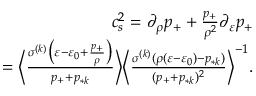<formula> <loc_0><loc_0><loc_500><loc_500>\begin{array} { r } { c _ { s } ^ { 2 } = \partial _ { \rho } p _ { + } + \frac { p _ { + } } { \rho ^ { 2 } } \partial _ { \varepsilon } p _ { + } } \\ { = \left \langle \frac { \sigma ^ { ( k ) } \left ( \varepsilon - \varepsilon _ { 0 } + \frac { p _ { + } } { \rho } \right ) } { p _ { + } + p _ { * k } } \right \rangle \left \langle \frac { \sigma ^ { ( k ) } ( \rho ( \varepsilon - \varepsilon _ { 0 } ) - p _ { * k } ) } { ( p _ { + } + p _ { * k } ) ^ { 2 } } \right \rangle ^ { - 1 } . } \end{array}</formula> 